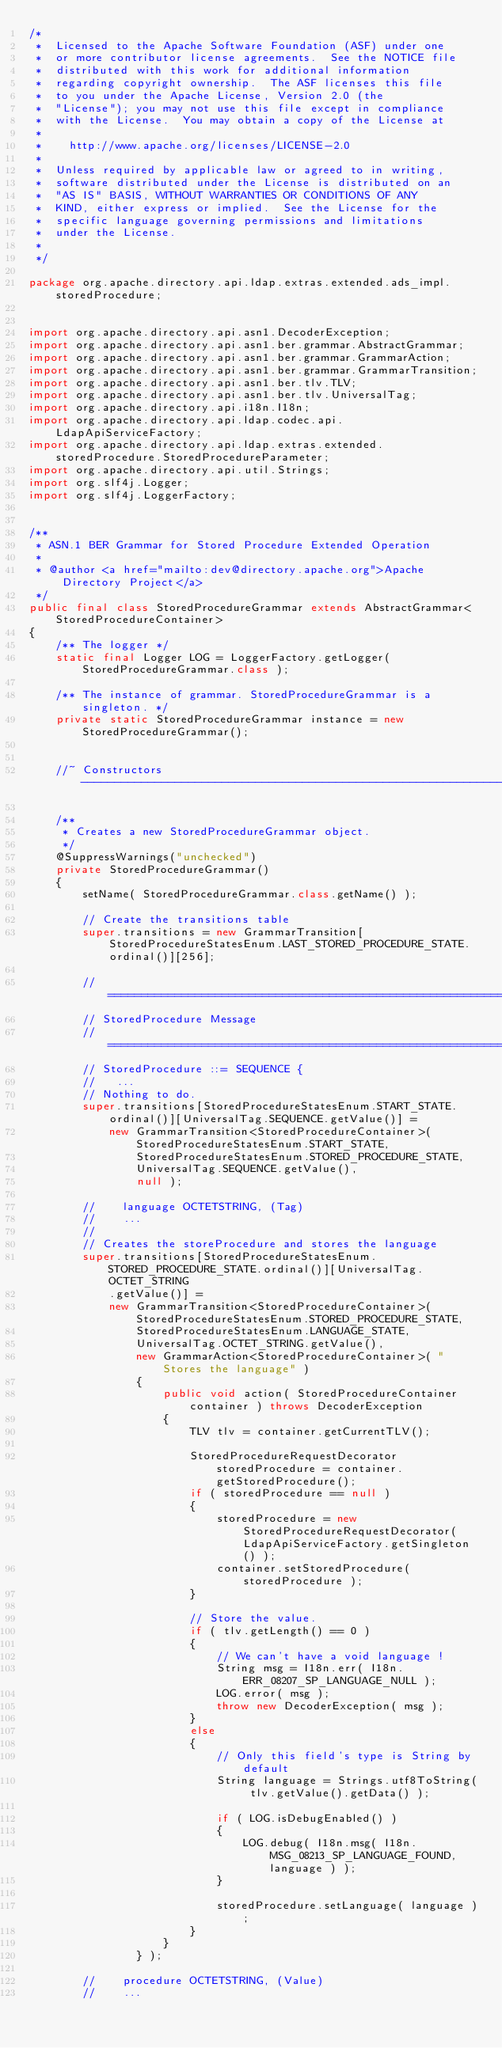Convert code to text. <code><loc_0><loc_0><loc_500><loc_500><_Java_>/*
 *  Licensed to the Apache Software Foundation (ASF) under one
 *  or more contributor license agreements.  See the NOTICE file
 *  distributed with this work for additional information
 *  regarding copyright ownership.  The ASF licenses this file
 *  to you under the Apache License, Version 2.0 (the
 *  "License"); you may not use this file except in compliance
 *  with the License.  You may obtain a copy of the License at
 *  
 *    http://www.apache.org/licenses/LICENSE-2.0
 *  
 *  Unless required by applicable law or agreed to in writing,
 *  software distributed under the License is distributed on an
 *  "AS IS" BASIS, WITHOUT WARRANTIES OR CONDITIONS OF ANY
 *  KIND, either express or implied.  See the License for the
 *  specific language governing permissions and limitations
 *  under the License. 
 *  
 */

package org.apache.directory.api.ldap.extras.extended.ads_impl.storedProcedure;


import org.apache.directory.api.asn1.DecoderException;
import org.apache.directory.api.asn1.ber.grammar.AbstractGrammar;
import org.apache.directory.api.asn1.ber.grammar.GrammarAction;
import org.apache.directory.api.asn1.ber.grammar.GrammarTransition;
import org.apache.directory.api.asn1.ber.tlv.TLV;
import org.apache.directory.api.asn1.ber.tlv.UniversalTag;
import org.apache.directory.api.i18n.I18n;
import org.apache.directory.api.ldap.codec.api.LdapApiServiceFactory;
import org.apache.directory.api.ldap.extras.extended.storedProcedure.StoredProcedureParameter;
import org.apache.directory.api.util.Strings;
import org.slf4j.Logger;
import org.slf4j.LoggerFactory;


/**
 * ASN.1 BER Grammar for Stored Procedure Extended Operation
 * 
 * @author <a href="mailto:dev@directory.apache.org">Apache Directory Project</a>
 */
public final class StoredProcedureGrammar extends AbstractGrammar<StoredProcedureContainer>
{
    /** The logger */
    static final Logger LOG = LoggerFactory.getLogger( StoredProcedureGrammar.class );

    /** The instance of grammar. StoredProcedureGrammar is a singleton. */
    private static StoredProcedureGrammar instance = new StoredProcedureGrammar();


    //~ Constructors -------------------------------------------------------------------------------

    /**
     * Creates a new StoredProcedureGrammar object.
     */
    @SuppressWarnings("unchecked")
    private StoredProcedureGrammar()
    {
        setName( StoredProcedureGrammar.class.getName() );

        // Create the transitions table
        super.transitions = new GrammarTransition[StoredProcedureStatesEnum.LAST_STORED_PROCEDURE_STATE.ordinal()][256];

        //============================================================================================
        // StoredProcedure Message
        //============================================================================================
        // StoredProcedure ::= SEQUENCE {
        //   ...
        // Nothing to do.
        super.transitions[StoredProcedureStatesEnum.START_STATE.ordinal()][UniversalTag.SEQUENCE.getValue()] =
            new GrammarTransition<StoredProcedureContainer>( StoredProcedureStatesEnum.START_STATE,
                StoredProcedureStatesEnum.STORED_PROCEDURE_STATE,
                UniversalTag.SEQUENCE.getValue(),
                null );

        //    language OCTETSTRING, (Tag)
        //    ...
        //
        // Creates the storeProcedure and stores the language
        super.transitions[StoredProcedureStatesEnum.STORED_PROCEDURE_STATE.ordinal()][UniversalTag.OCTET_STRING
            .getValue()] =
            new GrammarTransition<StoredProcedureContainer>( StoredProcedureStatesEnum.STORED_PROCEDURE_STATE,
                StoredProcedureStatesEnum.LANGUAGE_STATE,
                UniversalTag.OCTET_STRING.getValue(),
                new GrammarAction<StoredProcedureContainer>( "Stores the language" )
                {
                    public void action( StoredProcedureContainer container ) throws DecoderException
                    {
                        TLV tlv = container.getCurrentTLV();

                        StoredProcedureRequestDecorator storedProcedure = container.getStoredProcedure();
                        if ( storedProcedure == null )
                        {
                            storedProcedure = new StoredProcedureRequestDecorator( LdapApiServiceFactory.getSingleton() );
                            container.setStoredProcedure( storedProcedure );
                        }

                        // Store the value.
                        if ( tlv.getLength() == 0 )
                        {
                            // We can't have a void language !
                            String msg = I18n.err( I18n.ERR_08207_SP_LANGUAGE_NULL );
                            LOG.error( msg );
                            throw new DecoderException( msg );
                        }
                        else
                        {
                            // Only this field's type is String by default
                            String language = Strings.utf8ToString( tlv.getValue().getData() );

                            if ( LOG.isDebugEnabled() )
                            {
                                LOG.debug( I18n.msg( I18n.MSG_08213_SP_LANGUAGE_FOUND, language ) );
                            }

                            storedProcedure.setLanguage( language );
                        }
                    }
                } );

        //    procedure OCTETSTRING, (Value)
        //    ...</code> 